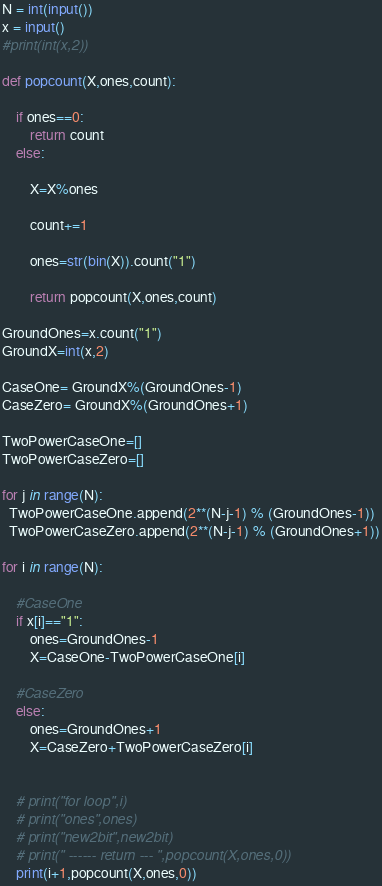Convert code to text. <code><loc_0><loc_0><loc_500><loc_500><_Python_>N = int(input())
x = input()
#print(int(x,2))

def popcount(X,ones,count): 
 
    if ones==0:
        return count
    else:
      
        X=X%ones
        
        count+=1
 
        ones=str(bin(X)).count("1")
        
        return popcount(X,ones,count)
 
GroundOnes=x.count("1")
GroundX=int(x,2)
 
CaseOne= GroundX%(GroundOnes-1)
CaseZero= GroundX%(GroundOnes+1)

TwoPowerCaseOne=[]
TwoPowerCaseZero=[]

for j in range(N):
  TwoPowerCaseOne.append(2**(N-j-1) % (GroundOnes-1))
  TwoPowerCaseZero.append(2**(N-j-1) % (GroundOnes+1))
  
for i in range(N):
    
    #CaseOne
    if x[i]=="1":
        ones=GroundOnes-1
        X=CaseOne-TwoPowerCaseOne[i]
        
    #CaseZero
    else:
        ones=GroundOnes+1
        X=CaseZero+TwoPowerCaseZero[i]
            
 
    # print("for loop",i)
    # print("ones",ones)
    # print("new2bit",new2bit)
    # print(" ------ return --- ",popcount(X,ones,0))
    print(i+1,popcount(X,ones,0))</code> 